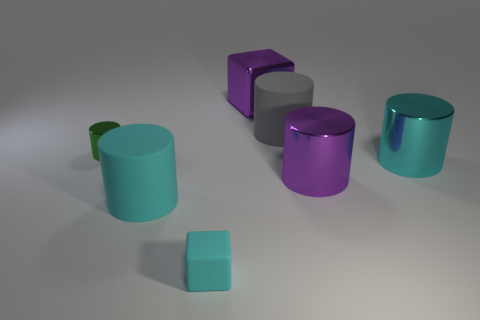What is the color of the small shiny object?
Keep it short and to the point. Green. There is a small thing that is in front of the green thing; is there a shiny thing that is on the right side of it?
Your answer should be compact. Yes. What is the material of the big gray object?
Your answer should be compact. Rubber. Are the large gray cylinder that is to the right of the tiny green cylinder and the large cyan cylinder to the left of the shiny cube made of the same material?
Give a very brief answer. Yes. Is there anything else of the same color as the big metallic block?
Offer a terse response. Yes. What is the color of the tiny thing that is the same shape as the large gray object?
Keep it short and to the point. Green. There is a cylinder that is both on the left side of the big gray thing and to the right of the green cylinder; what is its size?
Make the answer very short. Large. Is the shape of the matte object that is to the left of the tiny cyan matte thing the same as the small green metal thing that is behind the rubber cube?
Ensure brevity in your answer.  Yes. There is a matte thing that is the same color as the small rubber block; what shape is it?
Give a very brief answer. Cylinder. What number of objects have the same material as the small cube?
Keep it short and to the point. 2. 